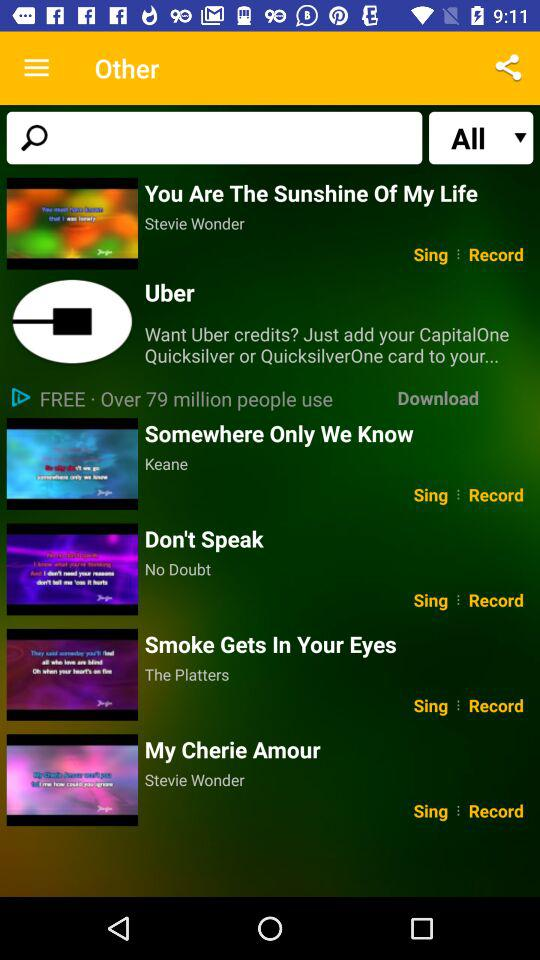By whom is the song "Don't speak" sung? The song "Don't speak" is sung by No Doubt. 